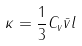<formula> <loc_0><loc_0><loc_500><loc_500>\kappa = \frac { 1 } { 3 } C _ { v } \bar { v } l</formula> 